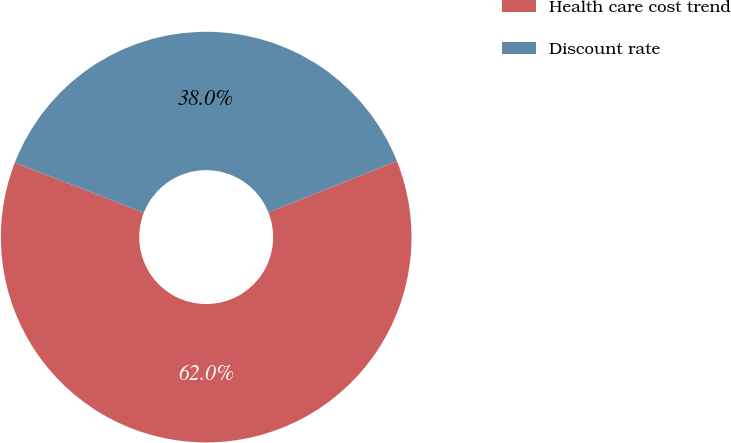Convert chart to OTSL. <chart><loc_0><loc_0><loc_500><loc_500><pie_chart><fcel>Health care cost trend<fcel>Discount rate<nl><fcel>61.96%<fcel>38.04%<nl></chart> 